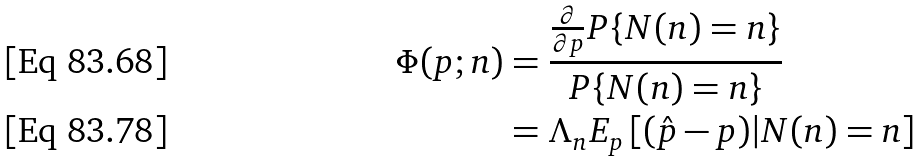Convert formula to latex. <formula><loc_0><loc_0><loc_500><loc_500>\Phi ( p ; n ) & = \frac { \frac { \partial } { \partial p } P \{ N ( n ) = n \} } { P \{ N ( n ) = n \} } \\ & = \Lambda _ { n } E _ { p } \left [ ( \hat { p } - p ) | N ( n ) = n \right ]</formula> 